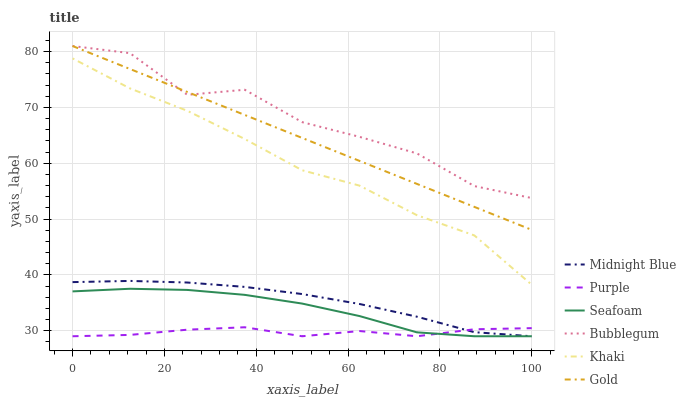Does Purple have the minimum area under the curve?
Answer yes or no. Yes. Does Bubblegum have the maximum area under the curve?
Answer yes or no. Yes. Does Midnight Blue have the minimum area under the curve?
Answer yes or no. No. Does Midnight Blue have the maximum area under the curve?
Answer yes or no. No. Is Gold the smoothest?
Answer yes or no. Yes. Is Bubblegum the roughest?
Answer yes or no. Yes. Is Midnight Blue the smoothest?
Answer yes or no. No. Is Midnight Blue the roughest?
Answer yes or no. No. Does Midnight Blue have the lowest value?
Answer yes or no. Yes. Does Gold have the lowest value?
Answer yes or no. No. Does Bubblegum have the highest value?
Answer yes or no. Yes. Does Midnight Blue have the highest value?
Answer yes or no. No. Is Seafoam less than Bubblegum?
Answer yes or no. Yes. Is Gold greater than Midnight Blue?
Answer yes or no. Yes. Does Purple intersect Midnight Blue?
Answer yes or no. Yes. Is Purple less than Midnight Blue?
Answer yes or no. No. Is Purple greater than Midnight Blue?
Answer yes or no. No. Does Seafoam intersect Bubblegum?
Answer yes or no. No. 